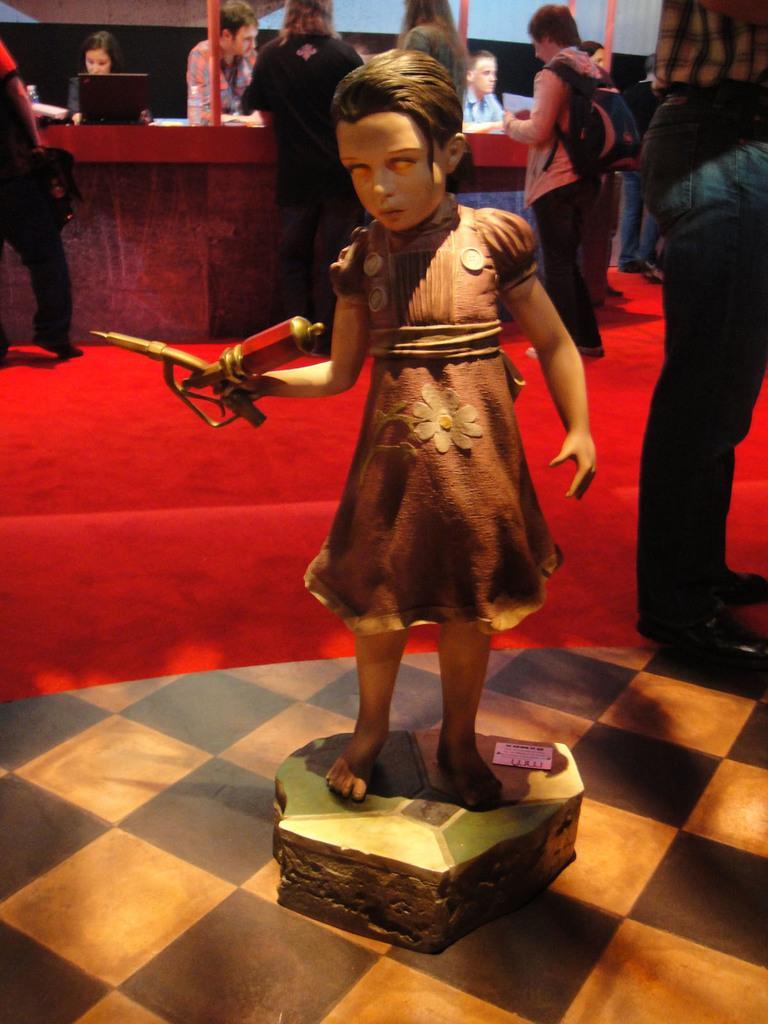In one or two sentences, can you explain what this image depicts? In the center of the image there is a depiction of a girl. In the background of the image there are people standing. There is red color carpet. At the bottom of the image there is floor. 